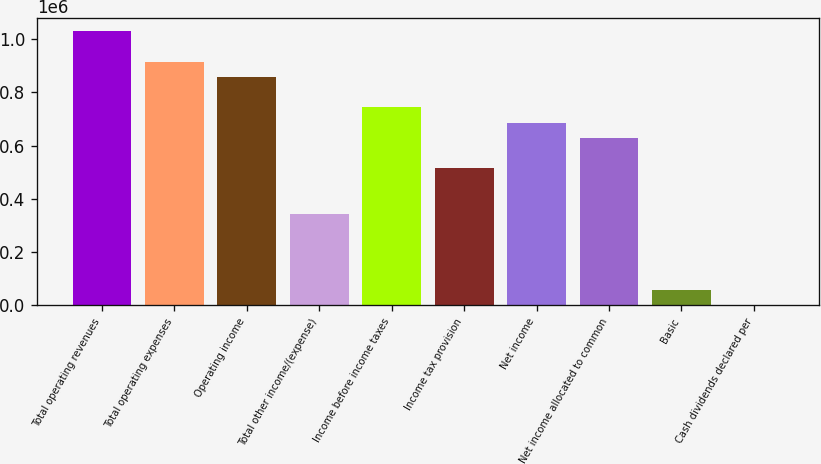Convert chart. <chart><loc_0><loc_0><loc_500><loc_500><bar_chart><fcel>Total operating revenues<fcel>Total operating expenses<fcel>Operating income<fcel>Total other income/(expense)<fcel>Income before income taxes<fcel>Income tax provision<fcel>Net income<fcel>Net income allocated to common<fcel>Basic<fcel>Cash dividends declared per<nl><fcel>1.02969e+06<fcel>915279<fcel>858074<fcel>343230<fcel>743665<fcel>514845<fcel>686460<fcel>629255<fcel>57206<fcel>1.16<nl></chart> 